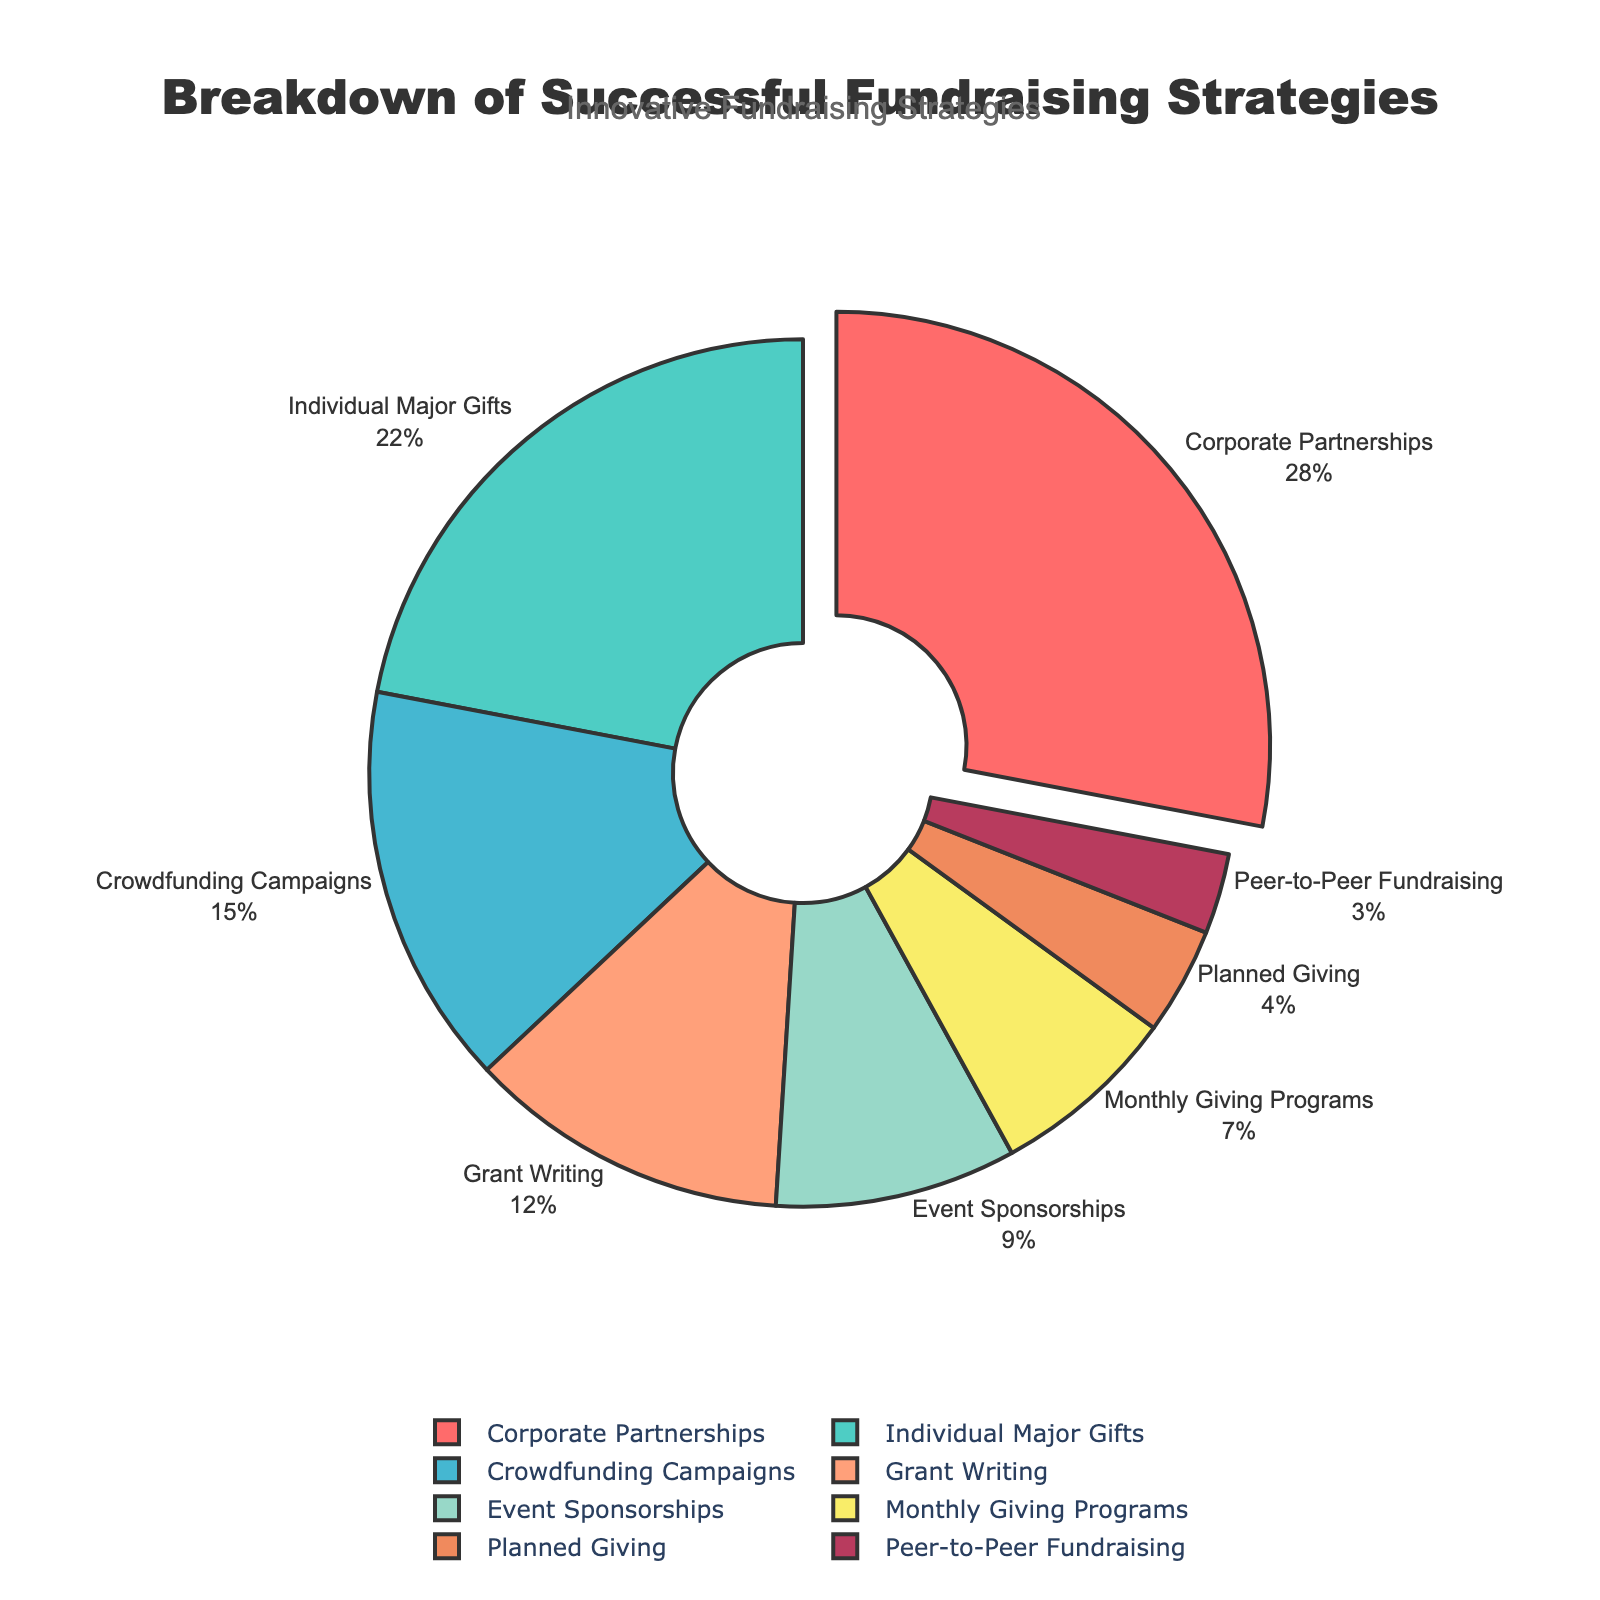What's the highest percentage fundraising strategy shown in the pie chart? The pie chart highlights the category with the highest percentage by pulling it out slightly from the rest. This category is "Corporate Partnerships" with 28%.
Answer: Corporate Partnerships, 28% Which three categories together contribute to exactly 50% of the total? Adding the percentages of the top categories: "Corporate Partnerships" (28%) + "Individual Major Gifts" (22%) = 50%.
Answer: Corporate Partnerships, Individual Major Gifts How much more does "Event Sponsorships" contribute compared to "Monthly Giving Programs"? "Event Sponsorships" contributes 9%, while "Monthly Giving Programs" contributes 7%. The difference is 9% - 7% = 2%.
Answer: 2% Which category has the least contribution, and what percentage is it? The category with the smallest segment in the pie chart is "Peer-to-Peer Fundraising" at 3%.
Answer: Peer-to-Peer Fundraising, 3% If "Grant Writing" and "Crowdfunding Campaigns" were combined into one category, what would be the new percentage for this combined category? The percentage for "Grant Writing" is 12%, and for "Crowdfunding Campaigns" it is 15%. Adding these gives 12% + 15% = 27%.
Answer: 27% How does the percentage of "Individual Major Gifts" compare to that of "Grant Writing"? "Individual Major Gifts" has a percentage of 22%, and "Grant Writing" has 12%. 22% is greater than 12%.
Answer: Individual Major Gifts is greater What's the cumulative percentage of all fundraising strategies except for the top two categories? The percentages for the non-top two categories: "Crowdfunding Campaigns" (15%) + "Grant Writing" (12%) + "Event Sponsorships" (9%) + "Monthly Giving Programs" (7%) + "Planned Giving" (4%) + "Peer-to-Peer Fundraising" (3%) = 50%.
Answer: 50% Are there more contributions from "Event Sponsorships" and "Monthly Giving Programs" together than "Grant Writing"? "Event Sponsorships" (9%) + "Monthly Giving Programs" (7%) = 16%, which is greater than "Grant Writing" at 12%.
Answer: Yes How many categories contribute less than 10% each? We look at the categories "Event Sponsorships" (9%), "Monthly Giving Programs" (7%), "Planned Giving" (4%), and "Peer-to-Peer Fundraising" (3%). There are 4 categories.
Answer: 4 